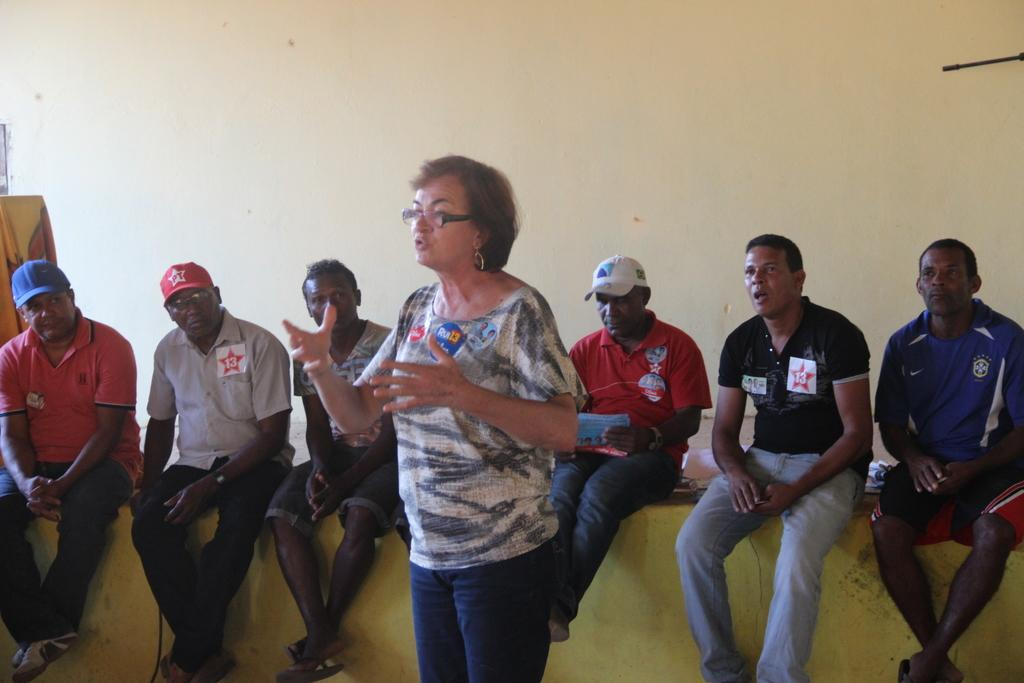Who is present in the image? There is a woman in the image. What can be seen in the background of the image? There are people sitting on a platform and a wall visible in the background. What type of curtain is hanging in front of the woman in the image? There is no curtain present in the image; the woman is not obscured by any fabric or object. 